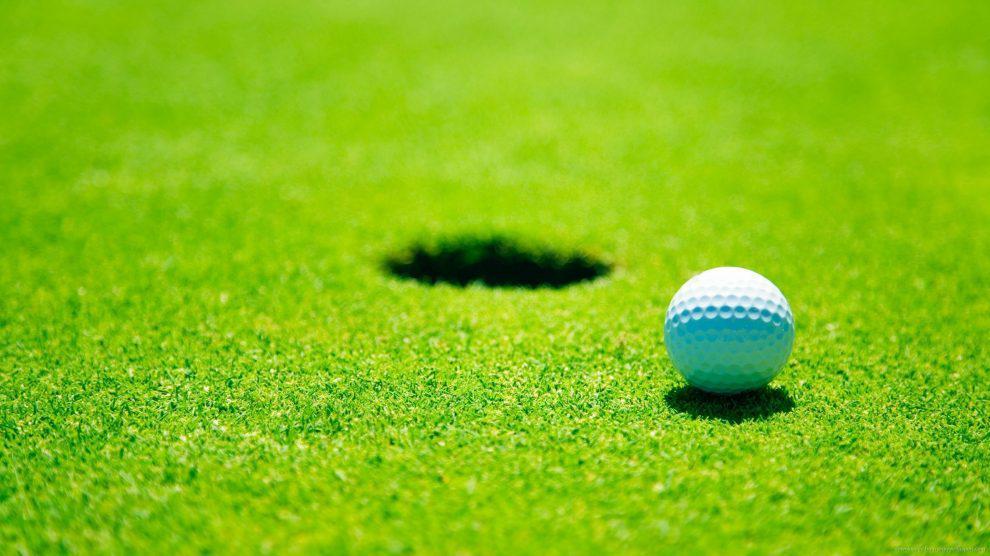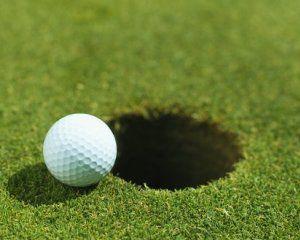The first image is the image on the left, the second image is the image on the right. For the images displayed, is the sentence "At least one golf ball is within about six inches of a hole with a pole sticking out of it." factually correct? Answer yes or no. No. The first image is the image on the left, the second image is the image on the right. Given the left and right images, does the statement "There are three golf balls, one on the left and two on the right, and no people." hold true? Answer yes or no. No. 